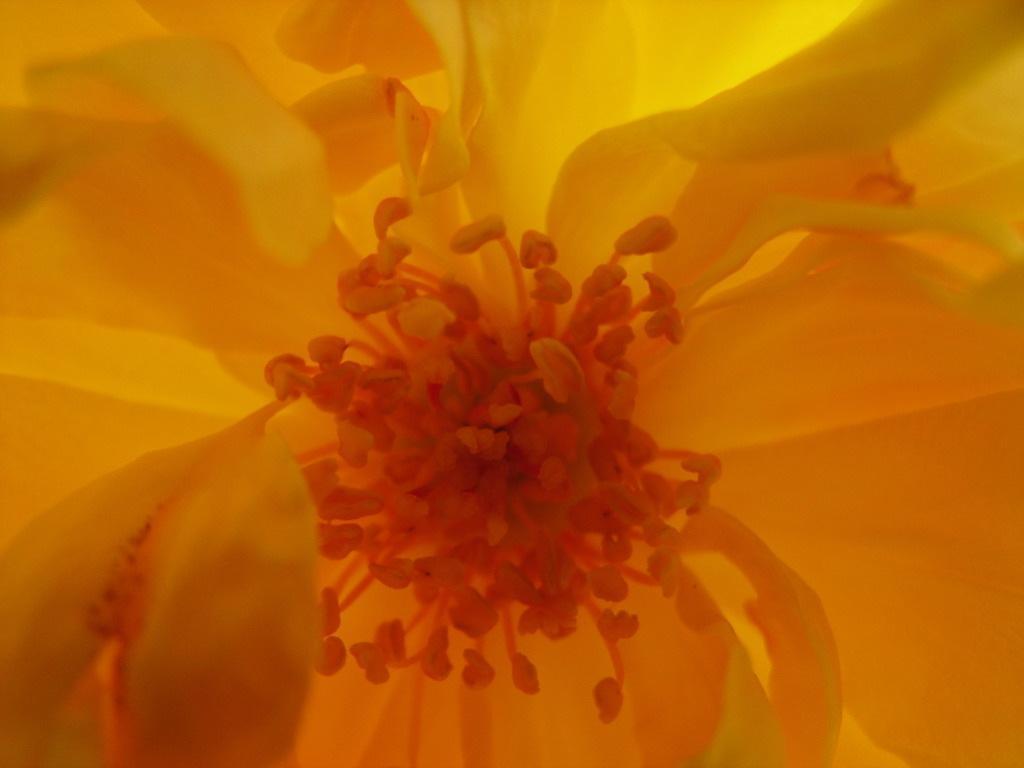In one or two sentences, can you explain what this image depicts? In this picture we can see yellow color flower. 